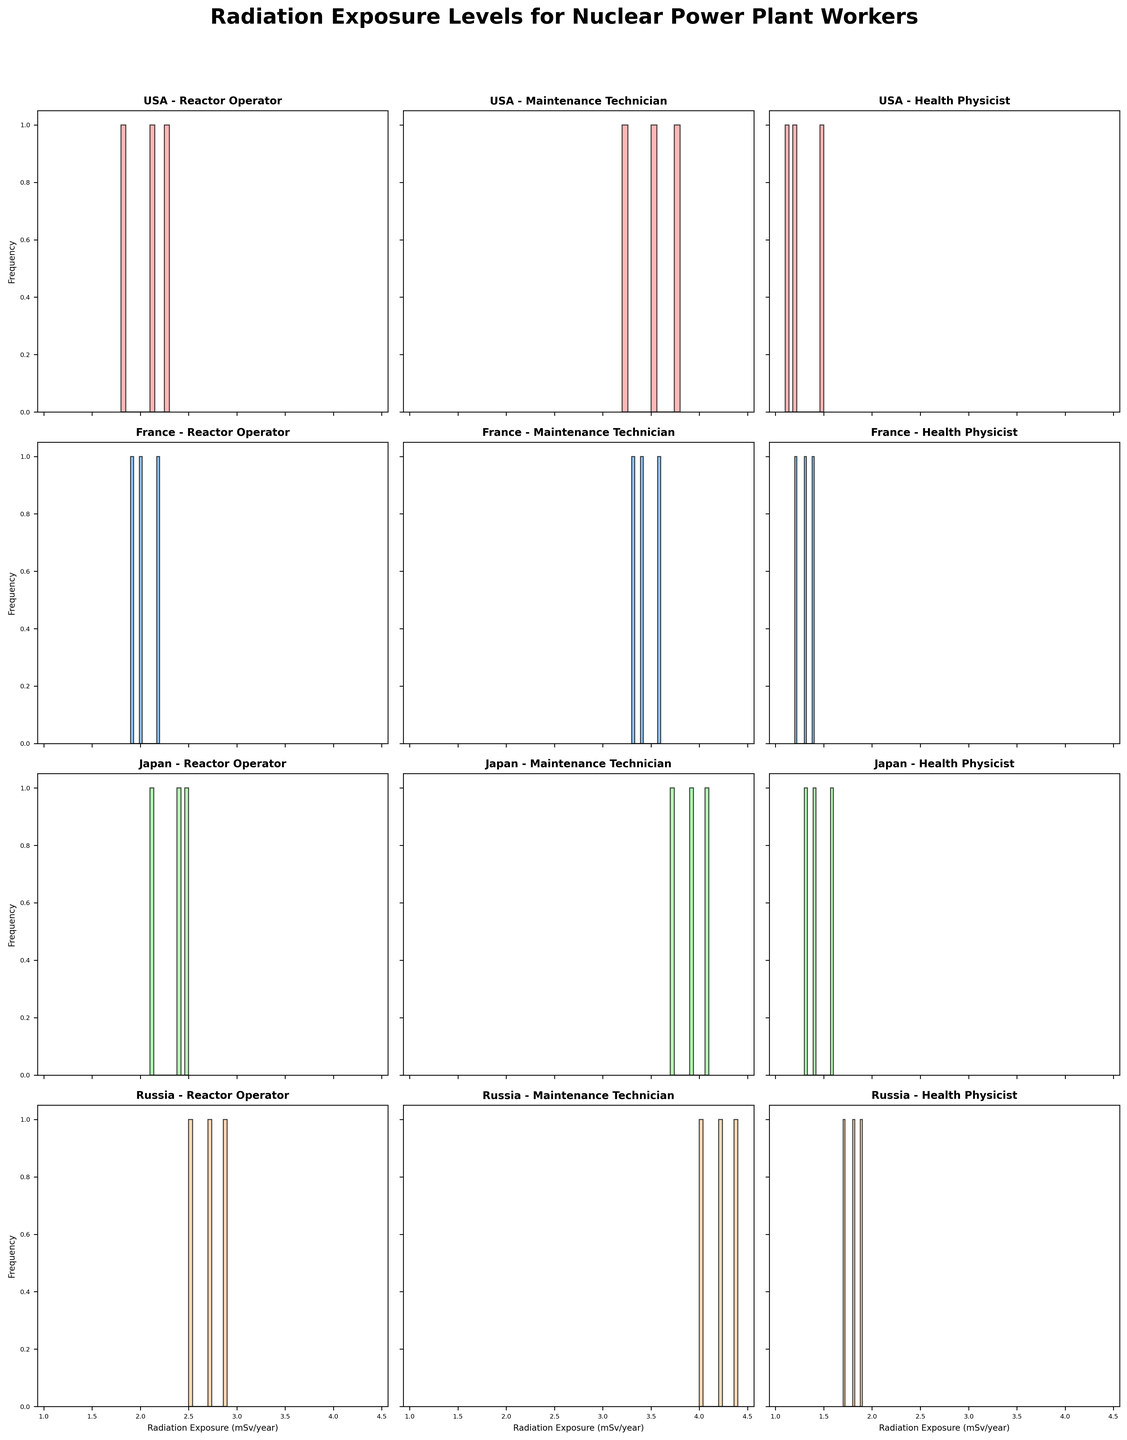What's the main title of the figure? The main title appears at the top of the figure and reads "Radiation Exposure Levels for Nuclear Power Plant Workers".
Answer: Radiation Exposure Levels for Nuclear Power Plant Workers Which axes label can be found repeatedly in the figure? The axes are labeled “Radiation Exposure (mSv/year)” for the x-axis and “Frequency” for the y-axis in each subplot.
Answer: Radiation Exposure (mSv/year) and Frequency Which country shows the highest level of radiation exposure for Reactor Operators? The subplots provide various histograms for each country and job role. Upon comparing the histograms of all countries under the "Reactor Operator" job role, Russia shows the highest levels.
Answer: Russia What are the colors used to differentiate between the countries in the histograms? The colors used in the histograms are distinct to help differentiate them. They are shades of red, blue, green, and orange.
Answer: Red, blue, green, orange How does the average radiation exposure for Health Physicists in Japan compare to those in the USA? To find the average, check the bins and heights of the bars for Health Physicists in the USA and Japan subplots. For Japan, the values (1.6, 1.3, 1.4) give an average of (1.6 + 1.3 + 1.4) / 3 = 1.43 mSv/year. For the USA, the values (1.2, 1.5, 1.1) yield (1.2 + 1.5 + 1.1) / 3 = 1.27 mSv/year. Thus, Japanese Health Physicists have a higher average exposure.
Answer: Japan Health Physicists have higher exposure Which job role in France has the highest average radiation exposure? Review the histograms for all job roles in the France plots. The Maintenance Technician role has data points (3.3, 3.6, 3.4), showing the highest bar clusters. Calculating the average, these values give an average of (3.3 + 3.6 + 3.4) / 3 = 3.43 mSv/year.
Answer: Maintenance Technician How does the radiation exposure of Maintenance Technicians in Russia compare to those in Japan? Examine the histograms for Maintenance Technicians in both countries. Russia's values, (4.2, 4.0, 4.4), averaging (4.2 + 4.0 + 4.4) / 3 = 4.2 mSv/year, are consistently higher than Japan's (3.9, 3.7, 4.1), which average (3.9 + 3.7 + 4.1) / 3 = 3.9 mSv/year.
Answer: Higher in Russia Identify the country-job role pair with the least radiation exposure. By examining the histogram bars for all the subplots, the Health Physicists in the USA subplot appear to have the smallest radiation exposure values (1.2, 1.5, 1.1).
Answer: Health Physicists in the USA How many subplots are displayed in the figure? There are multiple job roles and countries shown per subplot, with the arrangement in a grid format. There are four countries (USA, France, Japan, Russia) and three job roles (Reactor Operator, Maintenance Technician, Health Physicist), making a total of 4 x 3 = 12 subplots.
Answer: 12 Which job role has the widest range of radiation exposure levels in the data? To determine this, compare the range (max - min) for the job roles across subplots. Maintenance Technicians often show the widest range. For example, Russia's Maintenance Technician ranges from 4.0 to 4.4 (a span of 0.4), whereas the other roles have relatively smaller ranges.
Answer: Maintenance Technician 